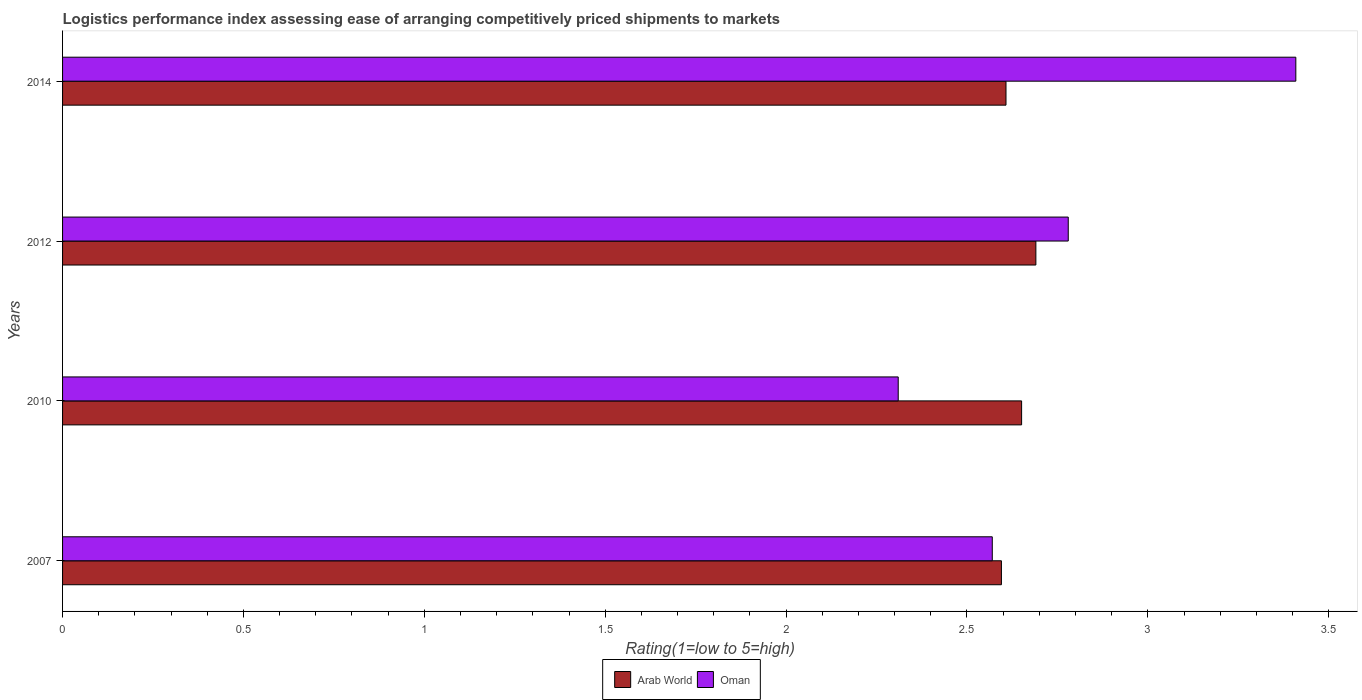How many different coloured bars are there?
Keep it short and to the point. 2. How many groups of bars are there?
Give a very brief answer. 4. Are the number of bars on each tick of the Y-axis equal?
Ensure brevity in your answer.  Yes. In how many cases, is the number of bars for a given year not equal to the number of legend labels?
Provide a succinct answer. 0. What is the Logistic performance index in Oman in 2007?
Offer a terse response. 2.57. Across all years, what is the maximum Logistic performance index in Arab World?
Your answer should be compact. 2.69. Across all years, what is the minimum Logistic performance index in Oman?
Provide a succinct answer. 2.31. In which year was the Logistic performance index in Oman maximum?
Offer a very short reply. 2014. In which year was the Logistic performance index in Oman minimum?
Make the answer very short. 2010. What is the total Logistic performance index in Arab World in the graph?
Provide a succinct answer. 10.54. What is the difference between the Logistic performance index in Oman in 2012 and that in 2014?
Offer a very short reply. -0.63. What is the difference between the Logistic performance index in Arab World in 2007 and the Logistic performance index in Oman in 2012?
Make the answer very short. -0.18. What is the average Logistic performance index in Arab World per year?
Make the answer very short. 2.64. In the year 2010, what is the difference between the Logistic performance index in Arab World and Logistic performance index in Oman?
Give a very brief answer. 0.34. In how many years, is the Logistic performance index in Arab World greater than 1.4 ?
Offer a terse response. 4. What is the ratio of the Logistic performance index in Arab World in 2007 to that in 2014?
Provide a short and direct response. 1. Is the Logistic performance index in Arab World in 2007 less than that in 2014?
Give a very brief answer. Yes. Is the difference between the Logistic performance index in Arab World in 2010 and 2012 greater than the difference between the Logistic performance index in Oman in 2010 and 2012?
Give a very brief answer. Yes. What is the difference between the highest and the second highest Logistic performance index in Oman?
Keep it short and to the point. 0.63. What is the difference between the highest and the lowest Logistic performance index in Arab World?
Make the answer very short. 0.1. Is the sum of the Logistic performance index in Oman in 2012 and 2014 greater than the maximum Logistic performance index in Arab World across all years?
Provide a succinct answer. Yes. What does the 1st bar from the top in 2010 represents?
Provide a succinct answer. Oman. What does the 2nd bar from the bottom in 2007 represents?
Ensure brevity in your answer.  Oman. How many bars are there?
Make the answer very short. 8. Are all the bars in the graph horizontal?
Offer a very short reply. Yes. How many years are there in the graph?
Your response must be concise. 4. What is the difference between two consecutive major ticks on the X-axis?
Ensure brevity in your answer.  0.5. Does the graph contain grids?
Your answer should be very brief. No. How are the legend labels stacked?
Keep it short and to the point. Horizontal. What is the title of the graph?
Your response must be concise. Logistics performance index assessing ease of arranging competitively priced shipments to markets. Does "St. Lucia" appear as one of the legend labels in the graph?
Keep it short and to the point. No. What is the label or title of the X-axis?
Your response must be concise. Rating(1=low to 5=high). What is the Rating(1=low to 5=high) in Arab World in 2007?
Provide a short and direct response. 2.6. What is the Rating(1=low to 5=high) of Oman in 2007?
Your answer should be very brief. 2.57. What is the Rating(1=low to 5=high) in Arab World in 2010?
Ensure brevity in your answer.  2.65. What is the Rating(1=low to 5=high) in Oman in 2010?
Keep it short and to the point. 2.31. What is the Rating(1=low to 5=high) in Arab World in 2012?
Offer a very short reply. 2.69. What is the Rating(1=low to 5=high) of Oman in 2012?
Offer a terse response. 2.78. What is the Rating(1=low to 5=high) of Arab World in 2014?
Keep it short and to the point. 2.61. What is the Rating(1=low to 5=high) in Oman in 2014?
Keep it short and to the point. 3.41. Across all years, what is the maximum Rating(1=low to 5=high) in Arab World?
Offer a terse response. 2.69. Across all years, what is the maximum Rating(1=low to 5=high) in Oman?
Offer a terse response. 3.41. Across all years, what is the minimum Rating(1=low to 5=high) of Arab World?
Give a very brief answer. 2.6. Across all years, what is the minimum Rating(1=low to 5=high) of Oman?
Make the answer very short. 2.31. What is the total Rating(1=low to 5=high) in Arab World in the graph?
Offer a very short reply. 10.54. What is the total Rating(1=low to 5=high) in Oman in the graph?
Provide a short and direct response. 11.07. What is the difference between the Rating(1=low to 5=high) of Arab World in 2007 and that in 2010?
Your answer should be very brief. -0.06. What is the difference between the Rating(1=low to 5=high) in Oman in 2007 and that in 2010?
Your answer should be compact. 0.26. What is the difference between the Rating(1=low to 5=high) of Arab World in 2007 and that in 2012?
Provide a succinct answer. -0.1. What is the difference between the Rating(1=low to 5=high) of Oman in 2007 and that in 2012?
Provide a succinct answer. -0.21. What is the difference between the Rating(1=low to 5=high) of Arab World in 2007 and that in 2014?
Your answer should be compact. -0.01. What is the difference between the Rating(1=low to 5=high) in Oman in 2007 and that in 2014?
Make the answer very short. -0.84. What is the difference between the Rating(1=low to 5=high) in Arab World in 2010 and that in 2012?
Your answer should be compact. -0.04. What is the difference between the Rating(1=low to 5=high) of Oman in 2010 and that in 2012?
Ensure brevity in your answer.  -0.47. What is the difference between the Rating(1=low to 5=high) in Arab World in 2010 and that in 2014?
Your answer should be compact. 0.04. What is the difference between the Rating(1=low to 5=high) in Oman in 2010 and that in 2014?
Make the answer very short. -1.1. What is the difference between the Rating(1=low to 5=high) of Arab World in 2012 and that in 2014?
Offer a very short reply. 0.08. What is the difference between the Rating(1=low to 5=high) of Oman in 2012 and that in 2014?
Ensure brevity in your answer.  -0.63. What is the difference between the Rating(1=low to 5=high) of Arab World in 2007 and the Rating(1=low to 5=high) of Oman in 2010?
Make the answer very short. 0.29. What is the difference between the Rating(1=low to 5=high) in Arab World in 2007 and the Rating(1=low to 5=high) in Oman in 2012?
Your answer should be very brief. -0.18. What is the difference between the Rating(1=low to 5=high) of Arab World in 2007 and the Rating(1=low to 5=high) of Oman in 2014?
Make the answer very short. -0.81. What is the difference between the Rating(1=low to 5=high) of Arab World in 2010 and the Rating(1=low to 5=high) of Oman in 2012?
Your answer should be compact. -0.13. What is the difference between the Rating(1=low to 5=high) of Arab World in 2010 and the Rating(1=low to 5=high) of Oman in 2014?
Keep it short and to the point. -0.76. What is the difference between the Rating(1=low to 5=high) in Arab World in 2012 and the Rating(1=low to 5=high) in Oman in 2014?
Offer a very short reply. -0.72. What is the average Rating(1=low to 5=high) of Arab World per year?
Your response must be concise. 2.64. What is the average Rating(1=low to 5=high) of Oman per year?
Offer a terse response. 2.77. In the year 2007, what is the difference between the Rating(1=low to 5=high) in Arab World and Rating(1=low to 5=high) in Oman?
Provide a short and direct response. 0.03. In the year 2010, what is the difference between the Rating(1=low to 5=high) in Arab World and Rating(1=low to 5=high) in Oman?
Ensure brevity in your answer.  0.34. In the year 2012, what is the difference between the Rating(1=low to 5=high) of Arab World and Rating(1=low to 5=high) of Oman?
Make the answer very short. -0.09. In the year 2014, what is the difference between the Rating(1=low to 5=high) of Arab World and Rating(1=low to 5=high) of Oman?
Your answer should be very brief. -0.8. What is the ratio of the Rating(1=low to 5=high) in Oman in 2007 to that in 2010?
Your answer should be compact. 1.11. What is the ratio of the Rating(1=low to 5=high) in Arab World in 2007 to that in 2012?
Make the answer very short. 0.96. What is the ratio of the Rating(1=low to 5=high) in Oman in 2007 to that in 2012?
Your response must be concise. 0.92. What is the ratio of the Rating(1=low to 5=high) in Oman in 2007 to that in 2014?
Your answer should be compact. 0.75. What is the ratio of the Rating(1=low to 5=high) in Oman in 2010 to that in 2012?
Keep it short and to the point. 0.83. What is the ratio of the Rating(1=low to 5=high) in Arab World in 2010 to that in 2014?
Provide a succinct answer. 1.02. What is the ratio of the Rating(1=low to 5=high) in Oman in 2010 to that in 2014?
Provide a short and direct response. 0.68. What is the ratio of the Rating(1=low to 5=high) in Arab World in 2012 to that in 2014?
Ensure brevity in your answer.  1.03. What is the ratio of the Rating(1=low to 5=high) in Oman in 2012 to that in 2014?
Your response must be concise. 0.82. What is the difference between the highest and the second highest Rating(1=low to 5=high) in Arab World?
Ensure brevity in your answer.  0.04. What is the difference between the highest and the second highest Rating(1=low to 5=high) in Oman?
Your response must be concise. 0.63. What is the difference between the highest and the lowest Rating(1=low to 5=high) of Arab World?
Ensure brevity in your answer.  0.1. What is the difference between the highest and the lowest Rating(1=low to 5=high) in Oman?
Give a very brief answer. 1.1. 